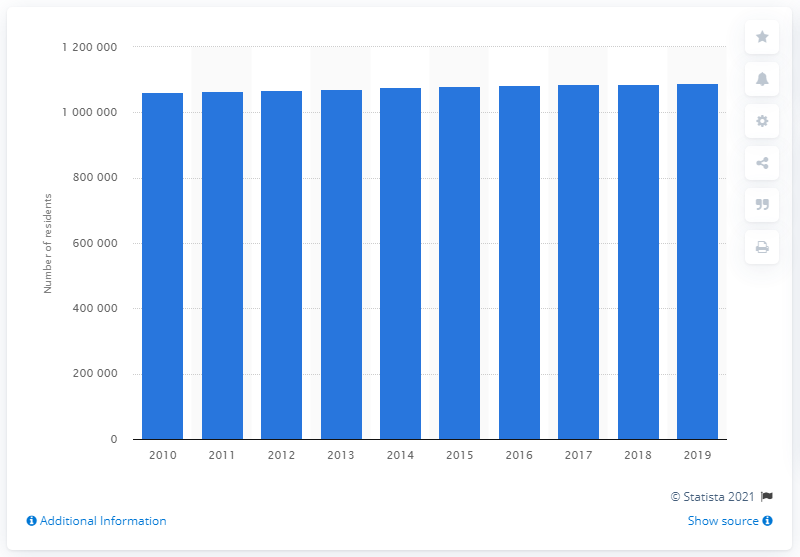Outline some significant characteristics in this image. In 2019, the Birmingham-Hoover metropolitan area was home to approximately 1,079,752 people. 